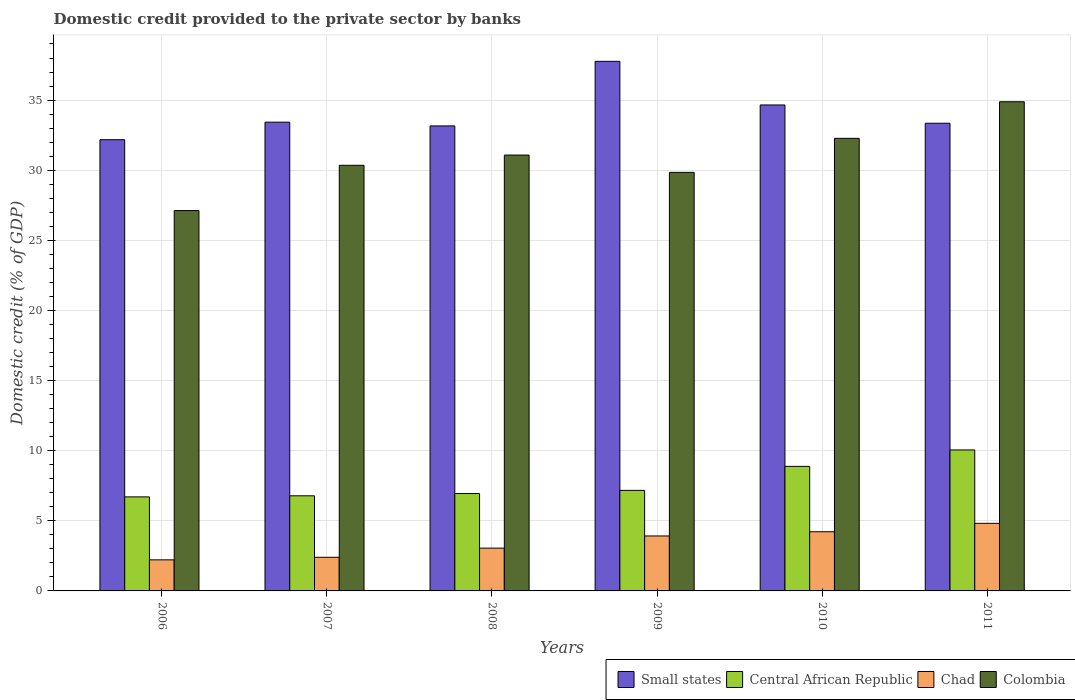How many different coloured bars are there?
Provide a short and direct response. 4. How many groups of bars are there?
Your answer should be very brief. 6. Are the number of bars per tick equal to the number of legend labels?
Make the answer very short. Yes. How many bars are there on the 4th tick from the left?
Your answer should be compact. 4. How many bars are there on the 3rd tick from the right?
Your answer should be very brief. 4. What is the label of the 4th group of bars from the left?
Your answer should be very brief. 2009. What is the domestic credit provided to the private sector by banks in Small states in 2009?
Your answer should be very brief. 37.76. Across all years, what is the maximum domestic credit provided to the private sector by banks in Small states?
Your answer should be compact. 37.76. Across all years, what is the minimum domestic credit provided to the private sector by banks in Central African Republic?
Keep it short and to the point. 6.71. In which year was the domestic credit provided to the private sector by banks in Chad maximum?
Provide a short and direct response. 2011. In which year was the domestic credit provided to the private sector by banks in Central African Republic minimum?
Offer a very short reply. 2006. What is the total domestic credit provided to the private sector by banks in Small states in the graph?
Provide a succinct answer. 204.53. What is the difference between the domestic credit provided to the private sector by banks in Chad in 2006 and that in 2009?
Ensure brevity in your answer.  -1.7. What is the difference between the domestic credit provided to the private sector by banks in Chad in 2010 and the domestic credit provided to the private sector by banks in Small states in 2006?
Your response must be concise. -27.96. What is the average domestic credit provided to the private sector by banks in Chad per year?
Keep it short and to the point. 3.44. In the year 2011, what is the difference between the domestic credit provided to the private sector by banks in Chad and domestic credit provided to the private sector by banks in Colombia?
Provide a succinct answer. -30.06. What is the ratio of the domestic credit provided to the private sector by banks in Central African Republic in 2006 to that in 2007?
Your response must be concise. 0.99. What is the difference between the highest and the second highest domestic credit provided to the private sector by banks in Central African Republic?
Offer a very short reply. 1.17. What is the difference between the highest and the lowest domestic credit provided to the private sector by banks in Small states?
Provide a short and direct response. 5.59. In how many years, is the domestic credit provided to the private sector by banks in Central African Republic greater than the average domestic credit provided to the private sector by banks in Central African Republic taken over all years?
Your response must be concise. 2. Is the sum of the domestic credit provided to the private sector by banks in Chad in 2008 and 2011 greater than the maximum domestic credit provided to the private sector by banks in Colombia across all years?
Offer a terse response. No. What does the 1st bar from the left in 2009 represents?
Keep it short and to the point. Small states. Is it the case that in every year, the sum of the domestic credit provided to the private sector by banks in Colombia and domestic credit provided to the private sector by banks in Chad is greater than the domestic credit provided to the private sector by banks in Central African Republic?
Your response must be concise. Yes. How many bars are there?
Your response must be concise. 24. Are all the bars in the graph horizontal?
Keep it short and to the point. No. What is the difference between two consecutive major ticks on the Y-axis?
Your answer should be compact. 5. Does the graph contain grids?
Offer a terse response. Yes. Where does the legend appear in the graph?
Your answer should be very brief. Bottom right. What is the title of the graph?
Provide a short and direct response. Domestic credit provided to the private sector by banks. Does "Slovak Republic" appear as one of the legend labels in the graph?
Provide a short and direct response. No. What is the label or title of the X-axis?
Make the answer very short. Years. What is the label or title of the Y-axis?
Make the answer very short. Domestic credit (% of GDP). What is the Domestic credit (% of GDP) in Small states in 2006?
Make the answer very short. 32.18. What is the Domestic credit (% of GDP) of Central African Republic in 2006?
Keep it short and to the point. 6.71. What is the Domestic credit (% of GDP) of Chad in 2006?
Offer a terse response. 2.22. What is the Domestic credit (% of GDP) of Colombia in 2006?
Provide a short and direct response. 27.12. What is the Domestic credit (% of GDP) in Small states in 2007?
Offer a very short reply. 33.43. What is the Domestic credit (% of GDP) in Central African Republic in 2007?
Keep it short and to the point. 6.78. What is the Domestic credit (% of GDP) in Chad in 2007?
Give a very brief answer. 2.4. What is the Domestic credit (% of GDP) in Colombia in 2007?
Offer a very short reply. 30.35. What is the Domestic credit (% of GDP) in Small states in 2008?
Make the answer very short. 33.16. What is the Domestic credit (% of GDP) of Central African Republic in 2008?
Make the answer very short. 6.94. What is the Domestic credit (% of GDP) of Chad in 2008?
Your answer should be very brief. 3.05. What is the Domestic credit (% of GDP) in Colombia in 2008?
Your response must be concise. 31.08. What is the Domestic credit (% of GDP) in Small states in 2009?
Provide a short and direct response. 37.76. What is the Domestic credit (% of GDP) in Central African Republic in 2009?
Provide a short and direct response. 7.17. What is the Domestic credit (% of GDP) of Chad in 2009?
Provide a succinct answer. 3.92. What is the Domestic credit (% of GDP) of Colombia in 2009?
Offer a terse response. 29.85. What is the Domestic credit (% of GDP) of Small states in 2010?
Ensure brevity in your answer.  34.65. What is the Domestic credit (% of GDP) in Central African Republic in 2010?
Provide a succinct answer. 8.88. What is the Domestic credit (% of GDP) in Chad in 2010?
Your answer should be very brief. 4.22. What is the Domestic credit (% of GDP) in Colombia in 2010?
Provide a succinct answer. 32.27. What is the Domestic credit (% of GDP) of Small states in 2011?
Your answer should be very brief. 33.35. What is the Domestic credit (% of GDP) of Central African Republic in 2011?
Ensure brevity in your answer.  10.05. What is the Domestic credit (% of GDP) of Chad in 2011?
Make the answer very short. 4.82. What is the Domestic credit (% of GDP) in Colombia in 2011?
Your answer should be compact. 34.88. Across all years, what is the maximum Domestic credit (% of GDP) of Small states?
Keep it short and to the point. 37.76. Across all years, what is the maximum Domestic credit (% of GDP) in Central African Republic?
Provide a short and direct response. 10.05. Across all years, what is the maximum Domestic credit (% of GDP) in Chad?
Offer a terse response. 4.82. Across all years, what is the maximum Domestic credit (% of GDP) of Colombia?
Your answer should be very brief. 34.88. Across all years, what is the minimum Domestic credit (% of GDP) in Small states?
Your response must be concise. 32.18. Across all years, what is the minimum Domestic credit (% of GDP) in Central African Republic?
Your answer should be very brief. 6.71. Across all years, what is the minimum Domestic credit (% of GDP) in Chad?
Your answer should be very brief. 2.22. Across all years, what is the minimum Domestic credit (% of GDP) in Colombia?
Provide a short and direct response. 27.12. What is the total Domestic credit (% of GDP) of Small states in the graph?
Give a very brief answer. 204.53. What is the total Domestic credit (% of GDP) in Central African Republic in the graph?
Offer a terse response. 46.54. What is the total Domestic credit (% of GDP) of Chad in the graph?
Your answer should be very brief. 20.62. What is the total Domestic credit (% of GDP) in Colombia in the graph?
Your answer should be very brief. 185.56. What is the difference between the Domestic credit (% of GDP) in Small states in 2006 and that in 2007?
Make the answer very short. -1.25. What is the difference between the Domestic credit (% of GDP) of Central African Republic in 2006 and that in 2007?
Give a very brief answer. -0.08. What is the difference between the Domestic credit (% of GDP) in Chad in 2006 and that in 2007?
Keep it short and to the point. -0.18. What is the difference between the Domestic credit (% of GDP) in Colombia in 2006 and that in 2007?
Your answer should be very brief. -3.23. What is the difference between the Domestic credit (% of GDP) in Small states in 2006 and that in 2008?
Offer a terse response. -0.98. What is the difference between the Domestic credit (% of GDP) of Central African Republic in 2006 and that in 2008?
Offer a very short reply. -0.24. What is the difference between the Domestic credit (% of GDP) of Chad in 2006 and that in 2008?
Give a very brief answer. -0.84. What is the difference between the Domestic credit (% of GDP) in Colombia in 2006 and that in 2008?
Give a very brief answer. -3.96. What is the difference between the Domestic credit (% of GDP) of Small states in 2006 and that in 2009?
Make the answer very short. -5.59. What is the difference between the Domestic credit (% of GDP) of Central African Republic in 2006 and that in 2009?
Provide a succinct answer. -0.46. What is the difference between the Domestic credit (% of GDP) in Chad in 2006 and that in 2009?
Offer a very short reply. -1.7. What is the difference between the Domestic credit (% of GDP) in Colombia in 2006 and that in 2009?
Offer a terse response. -2.72. What is the difference between the Domestic credit (% of GDP) of Small states in 2006 and that in 2010?
Offer a terse response. -2.48. What is the difference between the Domestic credit (% of GDP) in Central African Republic in 2006 and that in 2010?
Give a very brief answer. -2.18. What is the difference between the Domestic credit (% of GDP) of Chad in 2006 and that in 2010?
Keep it short and to the point. -2.01. What is the difference between the Domestic credit (% of GDP) of Colombia in 2006 and that in 2010?
Provide a succinct answer. -5.15. What is the difference between the Domestic credit (% of GDP) of Small states in 2006 and that in 2011?
Make the answer very short. -1.17. What is the difference between the Domestic credit (% of GDP) in Central African Republic in 2006 and that in 2011?
Ensure brevity in your answer.  -3.35. What is the difference between the Domestic credit (% of GDP) in Chad in 2006 and that in 2011?
Give a very brief answer. -2.6. What is the difference between the Domestic credit (% of GDP) of Colombia in 2006 and that in 2011?
Provide a succinct answer. -7.76. What is the difference between the Domestic credit (% of GDP) in Small states in 2007 and that in 2008?
Provide a succinct answer. 0.27. What is the difference between the Domestic credit (% of GDP) of Central African Republic in 2007 and that in 2008?
Offer a terse response. -0.16. What is the difference between the Domestic credit (% of GDP) in Chad in 2007 and that in 2008?
Give a very brief answer. -0.65. What is the difference between the Domestic credit (% of GDP) in Colombia in 2007 and that in 2008?
Make the answer very short. -0.73. What is the difference between the Domestic credit (% of GDP) in Small states in 2007 and that in 2009?
Ensure brevity in your answer.  -4.34. What is the difference between the Domestic credit (% of GDP) of Central African Republic in 2007 and that in 2009?
Provide a short and direct response. -0.39. What is the difference between the Domestic credit (% of GDP) of Chad in 2007 and that in 2009?
Your answer should be very brief. -1.52. What is the difference between the Domestic credit (% of GDP) in Colombia in 2007 and that in 2009?
Keep it short and to the point. 0.51. What is the difference between the Domestic credit (% of GDP) of Small states in 2007 and that in 2010?
Your answer should be very brief. -1.23. What is the difference between the Domestic credit (% of GDP) in Central African Republic in 2007 and that in 2010?
Your response must be concise. -2.1. What is the difference between the Domestic credit (% of GDP) of Chad in 2007 and that in 2010?
Your answer should be very brief. -1.82. What is the difference between the Domestic credit (% of GDP) of Colombia in 2007 and that in 2010?
Provide a succinct answer. -1.92. What is the difference between the Domestic credit (% of GDP) in Small states in 2007 and that in 2011?
Make the answer very short. 0.08. What is the difference between the Domestic credit (% of GDP) in Central African Republic in 2007 and that in 2011?
Make the answer very short. -3.27. What is the difference between the Domestic credit (% of GDP) of Chad in 2007 and that in 2011?
Provide a succinct answer. -2.42. What is the difference between the Domestic credit (% of GDP) in Colombia in 2007 and that in 2011?
Make the answer very short. -4.53. What is the difference between the Domestic credit (% of GDP) in Small states in 2008 and that in 2009?
Your answer should be very brief. -4.6. What is the difference between the Domestic credit (% of GDP) of Central African Republic in 2008 and that in 2009?
Provide a succinct answer. -0.23. What is the difference between the Domestic credit (% of GDP) in Chad in 2008 and that in 2009?
Provide a short and direct response. -0.87. What is the difference between the Domestic credit (% of GDP) in Colombia in 2008 and that in 2009?
Offer a terse response. 1.24. What is the difference between the Domestic credit (% of GDP) in Small states in 2008 and that in 2010?
Provide a short and direct response. -1.49. What is the difference between the Domestic credit (% of GDP) in Central African Republic in 2008 and that in 2010?
Provide a succinct answer. -1.94. What is the difference between the Domestic credit (% of GDP) in Chad in 2008 and that in 2010?
Your response must be concise. -1.17. What is the difference between the Domestic credit (% of GDP) in Colombia in 2008 and that in 2010?
Your response must be concise. -1.19. What is the difference between the Domestic credit (% of GDP) of Small states in 2008 and that in 2011?
Provide a short and direct response. -0.19. What is the difference between the Domestic credit (% of GDP) of Central African Republic in 2008 and that in 2011?
Make the answer very short. -3.11. What is the difference between the Domestic credit (% of GDP) of Chad in 2008 and that in 2011?
Offer a terse response. -1.77. What is the difference between the Domestic credit (% of GDP) of Colombia in 2008 and that in 2011?
Offer a very short reply. -3.8. What is the difference between the Domestic credit (% of GDP) of Small states in 2009 and that in 2010?
Give a very brief answer. 3.11. What is the difference between the Domestic credit (% of GDP) of Central African Republic in 2009 and that in 2010?
Your answer should be very brief. -1.71. What is the difference between the Domestic credit (% of GDP) in Chad in 2009 and that in 2010?
Provide a short and direct response. -0.3. What is the difference between the Domestic credit (% of GDP) of Colombia in 2009 and that in 2010?
Ensure brevity in your answer.  -2.43. What is the difference between the Domestic credit (% of GDP) in Small states in 2009 and that in 2011?
Your answer should be compact. 4.41. What is the difference between the Domestic credit (% of GDP) in Central African Republic in 2009 and that in 2011?
Offer a terse response. -2.88. What is the difference between the Domestic credit (% of GDP) of Chad in 2009 and that in 2011?
Make the answer very short. -0.9. What is the difference between the Domestic credit (% of GDP) of Colombia in 2009 and that in 2011?
Provide a short and direct response. -5.04. What is the difference between the Domestic credit (% of GDP) of Small states in 2010 and that in 2011?
Provide a short and direct response. 1.3. What is the difference between the Domestic credit (% of GDP) of Central African Republic in 2010 and that in 2011?
Your answer should be compact. -1.17. What is the difference between the Domestic credit (% of GDP) in Chad in 2010 and that in 2011?
Offer a very short reply. -0.6. What is the difference between the Domestic credit (% of GDP) in Colombia in 2010 and that in 2011?
Provide a short and direct response. -2.61. What is the difference between the Domestic credit (% of GDP) of Small states in 2006 and the Domestic credit (% of GDP) of Central African Republic in 2007?
Offer a terse response. 25.39. What is the difference between the Domestic credit (% of GDP) of Small states in 2006 and the Domestic credit (% of GDP) of Chad in 2007?
Keep it short and to the point. 29.78. What is the difference between the Domestic credit (% of GDP) in Small states in 2006 and the Domestic credit (% of GDP) in Colombia in 2007?
Provide a succinct answer. 1.83. What is the difference between the Domestic credit (% of GDP) of Central African Republic in 2006 and the Domestic credit (% of GDP) of Chad in 2007?
Your answer should be compact. 4.31. What is the difference between the Domestic credit (% of GDP) of Central African Republic in 2006 and the Domestic credit (% of GDP) of Colombia in 2007?
Your answer should be very brief. -23.64. What is the difference between the Domestic credit (% of GDP) of Chad in 2006 and the Domestic credit (% of GDP) of Colombia in 2007?
Ensure brevity in your answer.  -28.14. What is the difference between the Domestic credit (% of GDP) of Small states in 2006 and the Domestic credit (% of GDP) of Central African Republic in 2008?
Provide a succinct answer. 25.23. What is the difference between the Domestic credit (% of GDP) in Small states in 2006 and the Domestic credit (% of GDP) in Chad in 2008?
Ensure brevity in your answer.  29.12. What is the difference between the Domestic credit (% of GDP) of Small states in 2006 and the Domestic credit (% of GDP) of Colombia in 2008?
Your answer should be compact. 1.09. What is the difference between the Domestic credit (% of GDP) in Central African Republic in 2006 and the Domestic credit (% of GDP) in Chad in 2008?
Offer a very short reply. 3.65. What is the difference between the Domestic credit (% of GDP) of Central African Republic in 2006 and the Domestic credit (% of GDP) of Colombia in 2008?
Make the answer very short. -24.38. What is the difference between the Domestic credit (% of GDP) of Chad in 2006 and the Domestic credit (% of GDP) of Colombia in 2008?
Provide a short and direct response. -28.87. What is the difference between the Domestic credit (% of GDP) of Small states in 2006 and the Domestic credit (% of GDP) of Central African Republic in 2009?
Offer a terse response. 25.01. What is the difference between the Domestic credit (% of GDP) of Small states in 2006 and the Domestic credit (% of GDP) of Chad in 2009?
Provide a succinct answer. 28.26. What is the difference between the Domestic credit (% of GDP) of Small states in 2006 and the Domestic credit (% of GDP) of Colombia in 2009?
Give a very brief answer. 2.33. What is the difference between the Domestic credit (% of GDP) in Central African Republic in 2006 and the Domestic credit (% of GDP) in Chad in 2009?
Provide a short and direct response. 2.79. What is the difference between the Domestic credit (% of GDP) in Central African Republic in 2006 and the Domestic credit (% of GDP) in Colombia in 2009?
Provide a short and direct response. -23.14. What is the difference between the Domestic credit (% of GDP) in Chad in 2006 and the Domestic credit (% of GDP) in Colombia in 2009?
Provide a short and direct response. -27.63. What is the difference between the Domestic credit (% of GDP) of Small states in 2006 and the Domestic credit (% of GDP) of Central African Republic in 2010?
Ensure brevity in your answer.  23.29. What is the difference between the Domestic credit (% of GDP) in Small states in 2006 and the Domestic credit (% of GDP) in Chad in 2010?
Make the answer very short. 27.96. What is the difference between the Domestic credit (% of GDP) in Small states in 2006 and the Domestic credit (% of GDP) in Colombia in 2010?
Offer a very short reply. -0.1. What is the difference between the Domestic credit (% of GDP) of Central African Republic in 2006 and the Domestic credit (% of GDP) of Chad in 2010?
Your response must be concise. 2.49. What is the difference between the Domestic credit (% of GDP) of Central African Republic in 2006 and the Domestic credit (% of GDP) of Colombia in 2010?
Provide a short and direct response. -25.57. What is the difference between the Domestic credit (% of GDP) in Chad in 2006 and the Domestic credit (% of GDP) in Colombia in 2010?
Make the answer very short. -30.06. What is the difference between the Domestic credit (% of GDP) in Small states in 2006 and the Domestic credit (% of GDP) in Central African Republic in 2011?
Provide a short and direct response. 22.12. What is the difference between the Domestic credit (% of GDP) of Small states in 2006 and the Domestic credit (% of GDP) of Chad in 2011?
Your answer should be compact. 27.36. What is the difference between the Domestic credit (% of GDP) in Small states in 2006 and the Domestic credit (% of GDP) in Colombia in 2011?
Provide a short and direct response. -2.71. What is the difference between the Domestic credit (% of GDP) of Central African Republic in 2006 and the Domestic credit (% of GDP) of Chad in 2011?
Offer a very short reply. 1.89. What is the difference between the Domestic credit (% of GDP) in Central African Republic in 2006 and the Domestic credit (% of GDP) in Colombia in 2011?
Make the answer very short. -28.18. What is the difference between the Domestic credit (% of GDP) in Chad in 2006 and the Domestic credit (% of GDP) in Colombia in 2011?
Make the answer very short. -32.67. What is the difference between the Domestic credit (% of GDP) in Small states in 2007 and the Domestic credit (% of GDP) in Central African Republic in 2008?
Offer a terse response. 26.48. What is the difference between the Domestic credit (% of GDP) in Small states in 2007 and the Domestic credit (% of GDP) in Chad in 2008?
Provide a short and direct response. 30.37. What is the difference between the Domestic credit (% of GDP) in Small states in 2007 and the Domestic credit (% of GDP) in Colombia in 2008?
Your answer should be very brief. 2.34. What is the difference between the Domestic credit (% of GDP) of Central African Republic in 2007 and the Domestic credit (% of GDP) of Chad in 2008?
Provide a short and direct response. 3.73. What is the difference between the Domestic credit (% of GDP) in Central African Republic in 2007 and the Domestic credit (% of GDP) in Colombia in 2008?
Keep it short and to the point. -24.3. What is the difference between the Domestic credit (% of GDP) in Chad in 2007 and the Domestic credit (% of GDP) in Colombia in 2008?
Provide a short and direct response. -28.68. What is the difference between the Domestic credit (% of GDP) of Small states in 2007 and the Domestic credit (% of GDP) of Central African Republic in 2009?
Your response must be concise. 26.26. What is the difference between the Domestic credit (% of GDP) in Small states in 2007 and the Domestic credit (% of GDP) in Chad in 2009?
Your answer should be very brief. 29.51. What is the difference between the Domestic credit (% of GDP) in Small states in 2007 and the Domestic credit (% of GDP) in Colombia in 2009?
Make the answer very short. 3.58. What is the difference between the Domestic credit (% of GDP) of Central African Republic in 2007 and the Domestic credit (% of GDP) of Chad in 2009?
Provide a short and direct response. 2.86. What is the difference between the Domestic credit (% of GDP) of Central African Republic in 2007 and the Domestic credit (% of GDP) of Colombia in 2009?
Offer a terse response. -23.06. What is the difference between the Domestic credit (% of GDP) in Chad in 2007 and the Domestic credit (% of GDP) in Colombia in 2009?
Your answer should be very brief. -27.45. What is the difference between the Domestic credit (% of GDP) in Small states in 2007 and the Domestic credit (% of GDP) in Central African Republic in 2010?
Your answer should be compact. 24.54. What is the difference between the Domestic credit (% of GDP) of Small states in 2007 and the Domestic credit (% of GDP) of Chad in 2010?
Your response must be concise. 29.21. What is the difference between the Domestic credit (% of GDP) of Small states in 2007 and the Domestic credit (% of GDP) of Colombia in 2010?
Offer a very short reply. 1.15. What is the difference between the Domestic credit (% of GDP) in Central African Republic in 2007 and the Domestic credit (% of GDP) in Chad in 2010?
Provide a succinct answer. 2.56. What is the difference between the Domestic credit (% of GDP) of Central African Republic in 2007 and the Domestic credit (% of GDP) of Colombia in 2010?
Your response must be concise. -25.49. What is the difference between the Domestic credit (% of GDP) of Chad in 2007 and the Domestic credit (% of GDP) of Colombia in 2010?
Your answer should be compact. -29.88. What is the difference between the Domestic credit (% of GDP) in Small states in 2007 and the Domestic credit (% of GDP) in Central African Republic in 2011?
Keep it short and to the point. 23.37. What is the difference between the Domestic credit (% of GDP) in Small states in 2007 and the Domestic credit (% of GDP) in Chad in 2011?
Offer a terse response. 28.61. What is the difference between the Domestic credit (% of GDP) in Small states in 2007 and the Domestic credit (% of GDP) in Colombia in 2011?
Provide a succinct answer. -1.46. What is the difference between the Domestic credit (% of GDP) of Central African Republic in 2007 and the Domestic credit (% of GDP) of Chad in 2011?
Offer a terse response. 1.96. What is the difference between the Domestic credit (% of GDP) of Central African Republic in 2007 and the Domestic credit (% of GDP) of Colombia in 2011?
Your response must be concise. -28.1. What is the difference between the Domestic credit (% of GDP) of Chad in 2007 and the Domestic credit (% of GDP) of Colombia in 2011?
Provide a short and direct response. -32.48. What is the difference between the Domestic credit (% of GDP) of Small states in 2008 and the Domestic credit (% of GDP) of Central African Republic in 2009?
Make the answer very short. 25.99. What is the difference between the Domestic credit (% of GDP) of Small states in 2008 and the Domestic credit (% of GDP) of Chad in 2009?
Offer a very short reply. 29.24. What is the difference between the Domestic credit (% of GDP) of Small states in 2008 and the Domestic credit (% of GDP) of Colombia in 2009?
Offer a very short reply. 3.31. What is the difference between the Domestic credit (% of GDP) in Central African Republic in 2008 and the Domestic credit (% of GDP) in Chad in 2009?
Provide a short and direct response. 3.03. What is the difference between the Domestic credit (% of GDP) in Central African Republic in 2008 and the Domestic credit (% of GDP) in Colombia in 2009?
Provide a succinct answer. -22.9. What is the difference between the Domestic credit (% of GDP) of Chad in 2008 and the Domestic credit (% of GDP) of Colombia in 2009?
Ensure brevity in your answer.  -26.79. What is the difference between the Domestic credit (% of GDP) of Small states in 2008 and the Domestic credit (% of GDP) of Central African Republic in 2010?
Your answer should be compact. 24.28. What is the difference between the Domestic credit (% of GDP) in Small states in 2008 and the Domestic credit (% of GDP) in Chad in 2010?
Your answer should be very brief. 28.94. What is the difference between the Domestic credit (% of GDP) of Small states in 2008 and the Domestic credit (% of GDP) of Colombia in 2010?
Offer a terse response. 0.89. What is the difference between the Domestic credit (% of GDP) of Central African Republic in 2008 and the Domestic credit (% of GDP) of Chad in 2010?
Offer a terse response. 2.72. What is the difference between the Domestic credit (% of GDP) in Central African Republic in 2008 and the Domestic credit (% of GDP) in Colombia in 2010?
Your response must be concise. -25.33. What is the difference between the Domestic credit (% of GDP) of Chad in 2008 and the Domestic credit (% of GDP) of Colombia in 2010?
Offer a very short reply. -29.22. What is the difference between the Domestic credit (% of GDP) of Small states in 2008 and the Domestic credit (% of GDP) of Central African Republic in 2011?
Your answer should be compact. 23.11. What is the difference between the Domestic credit (% of GDP) in Small states in 2008 and the Domestic credit (% of GDP) in Chad in 2011?
Your answer should be compact. 28.34. What is the difference between the Domestic credit (% of GDP) in Small states in 2008 and the Domestic credit (% of GDP) in Colombia in 2011?
Your answer should be compact. -1.72. What is the difference between the Domestic credit (% of GDP) in Central African Republic in 2008 and the Domestic credit (% of GDP) in Chad in 2011?
Provide a short and direct response. 2.12. What is the difference between the Domestic credit (% of GDP) in Central African Republic in 2008 and the Domestic credit (% of GDP) in Colombia in 2011?
Offer a terse response. -27.94. What is the difference between the Domestic credit (% of GDP) of Chad in 2008 and the Domestic credit (% of GDP) of Colombia in 2011?
Provide a succinct answer. -31.83. What is the difference between the Domestic credit (% of GDP) in Small states in 2009 and the Domestic credit (% of GDP) in Central African Republic in 2010?
Your answer should be compact. 28.88. What is the difference between the Domestic credit (% of GDP) of Small states in 2009 and the Domestic credit (% of GDP) of Chad in 2010?
Your answer should be very brief. 33.54. What is the difference between the Domestic credit (% of GDP) in Small states in 2009 and the Domestic credit (% of GDP) in Colombia in 2010?
Offer a very short reply. 5.49. What is the difference between the Domestic credit (% of GDP) of Central African Republic in 2009 and the Domestic credit (% of GDP) of Chad in 2010?
Offer a terse response. 2.95. What is the difference between the Domestic credit (% of GDP) in Central African Republic in 2009 and the Domestic credit (% of GDP) in Colombia in 2010?
Offer a terse response. -25.1. What is the difference between the Domestic credit (% of GDP) of Chad in 2009 and the Domestic credit (% of GDP) of Colombia in 2010?
Make the answer very short. -28.35. What is the difference between the Domestic credit (% of GDP) in Small states in 2009 and the Domestic credit (% of GDP) in Central African Republic in 2011?
Your response must be concise. 27.71. What is the difference between the Domestic credit (% of GDP) of Small states in 2009 and the Domestic credit (% of GDP) of Chad in 2011?
Offer a terse response. 32.94. What is the difference between the Domestic credit (% of GDP) of Small states in 2009 and the Domestic credit (% of GDP) of Colombia in 2011?
Give a very brief answer. 2.88. What is the difference between the Domestic credit (% of GDP) in Central African Republic in 2009 and the Domestic credit (% of GDP) in Chad in 2011?
Make the answer very short. 2.35. What is the difference between the Domestic credit (% of GDP) of Central African Republic in 2009 and the Domestic credit (% of GDP) of Colombia in 2011?
Provide a succinct answer. -27.71. What is the difference between the Domestic credit (% of GDP) in Chad in 2009 and the Domestic credit (% of GDP) in Colombia in 2011?
Your answer should be very brief. -30.96. What is the difference between the Domestic credit (% of GDP) of Small states in 2010 and the Domestic credit (% of GDP) of Central African Republic in 2011?
Your answer should be very brief. 24.6. What is the difference between the Domestic credit (% of GDP) in Small states in 2010 and the Domestic credit (% of GDP) in Chad in 2011?
Offer a very short reply. 29.83. What is the difference between the Domestic credit (% of GDP) of Small states in 2010 and the Domestic credit (% of GDP) of Colombia in 2011?
Make the answer very short. -0.23. What is the difference between the Domestic credit (% of GDP) of Central African Republic in 2010 and the Domestic credit (% of GDP) of Chad in 2011?
Give a very brief answer. 4.06. What is the difference between the Domestic credit (% of GDP) of Central African Republic in 2010 and the Domestic credit (% of GDP) of Colombia in 2011?
Keep it short and to the point. -26. What is the difference between the Domestic credit (% of GDP) in Chad in 2010 and the Domestic credit (% of GDP) in Colombia in 2011?
Give a very brief answer. -30.66. What is the average Domestic credit (% of GDP) in Small states per year?
Ensure brevity in your answer.  34.09. What is the average Domestic credit (% of GDP) in Central African Republic per year?
Provide a short and direct response. 7.76. What is the average Domestic credit (% of GDP) in Chad per year?
Provide a short and direct response. 3.44. What is the average Domestic credit (% of GDP) in Colombia per year?
Offer a terse response. 30.93. In the year 2006, what is the difference between the Domestic credit (% of GDP) in Small states and Domestic credit (% of GDP) in Central African Republic?
Make the answer very short. 25.47. In the year 2006, what is the difference between the Domestic credit (% of GDP) in Small states and Domestic credit (% of GDP) in Chad?
Offer a very short reply. 29.96. In the year 2006, what is the difference between the Domestic credit (% of GDP) in Small states and Domestic credit (% of GDP) in Colombia?
Provide a succinct answer. 5.05. In the year 2006, what is the difference between the Domestic credit (% of GDP) of Central African Republic and Domestic credit (% of GDP) of Chad?
Offer a very short reply. 4.49. In the year 2006, what is the difference between the Domestic credit (% of GDP) in Central African Republic and Domestic credit (% of GDP) in Colombia?
Your answer should be compact. -20.42. In the year 2006, what is the difference between the Domestic credit (% of GDP) of Chad and Domestic credit (% of GDP) of Colombia?
Provide a succinct answer. -24.91. In the year 2007, what is the difference between the Domestic credit (% of GDP) of Small states and Domestic credit (% of GDP) of Central African Republic?
Make the answer very short. 26.64. In the year 2007, what is the difference between the Domestic credit (% of GDP) of Small states and Domestic credit (% of GDP) of Chad?
Your answer should be compact. 31.03. In the year 2007, what is the difference between the Domestic credit (% of GDP) in Small states and Domestic credit (% of GDP) in Colombia?
Make the answer very short. 3.08. In the year 2007, what is the difference between the Domestic credit (% of GDP) in Central African Republic and Domestic credit (% of GDP) in Chad?
Your answer should be compact. 4.39. In the year 2007, what is the difference between the Domestic credit (% of GDP) of Central African Republic and Domestic credit (% of GDP) of Colombia?
Provide a short and direct response. -23.57. In the year 2007, what is the difference between the Domestic credit (% of GDP) of Chad and Domestic credit (% of GDP) of Colombia?
Provide a short and direct response. -27.95. In the year 2008, what is the difference between the Domestic credit (% of GDP) in Small states and Domestic credit (% of GDP) in Central African Republic?
Ensure brevity in your answer.  26.22. In the year 2008, what is the difference between the Domestic credit (% of GDP) in Small states and Domestic credit (% of GDP) in Chad?
Your answer should be very brief. 30.11. In the year 2008, what is the difference between the Domestic credit (% of GDP) of Small states and Domestic credit (% of GDP) of Colombia?
Your response must be concise. 2.08. In the year 2008, what is the difference between the Domestic credit (% of GDP) in Central African Republic and Domestic credit (% of GDP) in Chad?
Provide a short and direct response. 3.89. In the year 2008, what is the difference between the Domestic credit (% of GDP) in Central African Republic and Domestic credit (% of GDP) in Colombia?
Give a very brief answer. -24.14. In the year 2008, what is the difference between the Domestic credit (% of GDP) in Chad and Domestic credit (% of GDP) in Colombia?
Your answer should be very brief. -28.03. In the year 2009, what is the difference between the Domestic credit (% of GDP) of Small states and Domestic credit (% of GDP) of Central African Republic?
Provide a short and direct response. 30.59. In the year 2009, what is the difference between the Domestic credit (% of GDP) of Small states and Domestic credit (% of GDP) of Chad?
Your answer should be compact. 33.84. In the year 2009, what is the difference between the Domestic credit (% of GDP) in Small states and Domestic credit (% of GDP) in Colombia?
Your answer should be compact. 7.92. In the year 2009, what is the difference between the Domestic credit (% of GDP) in Central African Republic and Domestic credit (% of GDP) in Chad?
Your answer should be very brief. 3.25. In the year 2009, what is the difference between the Domestic credit (% of GDP) of Central African Republic and Domestic credit (% of GDP) of Colombia?
Give a very brief answer. -22.68. In the year 2009, what is the difference between the Domestic credit (% of GDP) of Chad and Domestic credit (% of GDP) of Colombia?
Your answer should be compact. -25.93. In the year 2010, what is the difference between the Domestic credit (% of GDP) in Small states and Domestic credit (% of GDP) in Central African Republic?
Ensure brevity in your answer.  25.77. In the year 2010, what is the difference between the Domestic credit (% of GDP) in Small states and Domestic credit (% of GDP) in Chad?
Your response must be concise. 30.43. In the year 2010, what is the difference between the Domestic credit (% of GDP) of Small states and Domestic credit (% of GDP) of Colombia?
Your answer should be compact. 2.38. In the year 2010, what is the difference between the Domestic credit (% of GDP) of Central African Republic and Domestic credit (% of GDP) of Chad?
Give a very brief answer. 4.66. In the year 2010, what is the difference between the Domestic credit (% of GDP) in Central African Republic and Domestic credit (% of GDP) in Colombia?
Your answer should be very brief. -23.39. In the year 2010, what is the difference between the Domestic credit (% of GDP) of Chad and Domestic credit (% of GDP) of Colombia?
Your answer should be compact. -28.05. In the year 2011, what is the difference between the Domestic credit (% of GDP) of Small states and Domestic credit (% of GDP) of Central African Republic?
Provide a short and direct response. 23.3. In the year 2011, what is the difference between the Domestic credit (% of GDP) in Small states and Domestic credit (% of GDP) in Chad?
Ensure brevity in your answer.  28.53. In the year 2011, what is the difference between the Domestic credit (% of GDP) of Small states and Domestic credit (% of GDP) of Colombia?
Your response must be concise. -1.53. In the year 2011, what is the difference between the Domestic credit (% of GDP) in Central African Republic and Domestic credit (% of GDP) in Chad?
Your response must be concise. 5.23. In the year 2011, what is the difference between the Domestic credit (% of GDP) of Central African Republic and Domestic credit (% of GDP) of Colombia?
Offer a terse response. -24.83. In the year 2011, what is the difference between the Domestic credit (% of GDP) in Chad and Domestic credit (% of GDP) in Colombia?
Make the answer very short. -30.06. What is the ratio of the Domestic credit (% of GDP) of Small states in 2006 to that in 2007?
Give a very brief answer. 0.96. What is the ratio of the Domestic credit (% of GDP) of Central African Republic in 2006 to that in 2007?
Your answer should be very brief. 0.99. What is the ratio of the Domestic credit (% of GDP) of Chad in 2006 to that in 2007?
Your answer should be compact. 0.92. What is the ratio of the Domestic credit (% of GDP) of Colombia in 2006 to that in 2007?
Offer a terse response. 0.89. What is the ratio of the Domestic credit (% of GDP) in Small states in 2006 to that in 2008?
Give a very brief answer. 0.97. What is the ratio of the Domestic credit (% of GDP) in Central African Republic in 2006 to that in 2008?
Offer a terse response. 0.97. What is the ratio of the Domestic credit (% of GDP) of Chad in 2006 to that in 2008?
Your answer should be very brief. 0.73. What is the ratio of the Domestic credit (% of GDP) of Colombia in 2006 to that in 2008?
Offer a very short reply. 0.87. What is the ratio of the Domestic credit (% of GDP) of Small states in 2006 to that in 2009?
Keep it short and to the point. 0.85. What is the ratio of the Domestic credit (% of GDP) in Central African Republic in 2006 to that in 2009?
Make the answer very short. 0.94. What is the ratio of the Domestic credit (% of GDP) in Chad in 2006 to that in 2009?
Your answer should be very brief. 0.57. What is the ratio of the Domestic credit (% of GDP) of Colombia in 2006 to that in 2009?
Offer a very short reply. 0.91. What is the ratio of the Domestic credit (% of GDP) of Small states in 2006 to that in 2010?
Make the answer very short. 0.93. What is the ratio of the Domestic credit (% of GDP) of Central African Republic in 2006 to that in 2010?
Offer a very short reply. 0.76. What is the ratio of the Domestic credit (% of GDP) in Chad in 2006 to that in 2010?
Offer a very short reply. 0.52. What is the ratio of the Domestic credit (% of GDP) of Colombia in 2006 to that in 2010?
Provide a succinct answer. 0.84. What is the ratio of the Domestic credit (% of GDP) of Small states in 2006 to that in 2011?
Make the answer very short. 0.96. What is the ratio of the Domestic credit (% of GDP) of Central African Republic in 2006 to that in 2011?
Your response must be concise. 0.67. What is the ratio of the Domestic credit (% of GDP) in Chad in 2006 to that in 2011?
Provide a short and direct response. 0.46. What is the ratio of the Domestic credit (% of GDP) of Colombia in 2006 to that in 2011?
Your answer should be compact. 0.78. What is the ratio of the Domestic credit (% of GDP) in Small states in 2007 to that in 2008?
Your answer should be very brief. 1.01. What is the ratio of the Domestic credit (% of GDP) in Central African Republic in 2007 to that in 2008?
Provide a short and direct response. 0.98. What is the ratio of the Domestic credit (% of GDP) in Chad in 2007 to that in 2008?
Offer a very short reply. 0.79. What is the ratio of the Domestic credit (% of GDP) of Colombia in 2007 to that in 2008?
Ensure brevity in your answer.  0.98. What is the ratio of the Domestic credit (% of GDP) of Small states in 2007 to that in 2009?
Your answer should be very brief. 0.89. What is the ratio of the Domestic credit (% of GDP) of Central African Republic in 2007 to that in 2009?
Offer a very short reply. 0.95. What is the ratio of the Domestic credit (% of GDP) in Chad in 2007 to that in 2009?
Make the answer very short. 0.61. What is the ratio of the Domestic credit (% of GDP) in Colombia in 2007 to that in 2009?
Your response must be concise. 1.02. What is the ratio of the Domestic credit (% of GDP) in Small states in 2007 to that in 2010?
Give a very brief answer. 0.96. What is the ratio of the Domestic credit (% of GDP) of Central African Republic in 2007 to that in 2010?
Ensure brevity in your answer.  0.76. What is the ratio of the Domestic credit (% of GDP) of Chad in 2007 to that in 2010?
Offer a very short reply. 0.57. What is the ratio of the Domestic credit (% of GDP) of Colombia in 2007 to that in 2010?
Ensure brevity in your answer.  0.94. What is the ratio of the Domestic credit (% of GDP) of Central African Republic in 2007 to that in 2011?
Make the answer very short. 0.67. What is the ratio of the Domestic credit (% of GDP) of Chad in 2007 to that in 2011?
Your response must be concise. 0.5. What is the ratio of the Domestic credit (% of GDP) of Colombia in 2007 to that in 2011?
Give a very brief answer. 0.87. What is the ratio of the Domestic credit (% of GDP) in Small states in 2008 to that in 2009?
Offer a terse response. 0.88. What is the ratio of the Domestic credit (% of GDP) in Central African Republic in 2008 to that in 2009?
Make the answer very short. 0.97. What is the ratio of the Domestic credit (% of GDP) of Chad in 2008 to that in 2009?
Offer a terse response. 0.78. What is the ratio of the Domestic credit (% of GDP) in Colombia in 2008 to that in 2009?
Provide a succinct answer. 1.04. What is the ratio of the Domestic credit (% of GDP) in Small states in 2008 to that in 2010?
Your answer should be compact. 0.96. What is the ratio of the Domestic credit (% of GDP) in Central African Republic in 2008 to that in 2010?
Your response must be concise. 0.78. What is the ratio of the Domestic credit (% of GDP) in Chad in 2008 to that in 2010?
Give a very brief answer. 0.72. What is the ratio of the Domestic credit (% of GDP) in Colombia in 2008 to that in 2010?
Provide a succinct answer. 0.96. What is the ratio of the Domestic credit (% of GDP) of Small states in 2008 to that in 2011?
Provide a succinct answer. 0.99. What is the ratio of the Domestic credit (% of GDP) in Central African Republic in 2008 to that in 2011?
Offer a very short reply. 0.69. What is the ratio of the Domestic credit (% of GDP) in Chad in 2008 to that in 2011?
Give a very brief answer. 0.63. What is the ratio of the Domestic credit (% of GDP) in Colombia in 2008 to that in 2011?
Give a very brief answer. 0.89. What is the ratio of the Domestic credit (% of GDP) of Small states in 2009 to that in 2010?
Your answer should be compact. 1.09. What is the ratio of the Domestic credit (% of GDP) of Central African Republic in 2009 to that in 2010?
Offer a very short reply. 0.81. What is the ratio of the Domestic credit (% of GDP) in Chad in 2009 to that in 2010?
Ensure brevity in your answer.  0.93. What is the ratio of the Domestic credit (% of GDP) in Colombia in 2009 to that in 2010?
Keep it short and to the point. 0.92. What is the ratio of the Domestic credit (% of GDP) in Small states in 2009 to that in 2011?
Offer a very short reply. 1.13. What is the ratio of the Domestic credit (% of GDP) in Central African Republic in 2009 to that in 2011?
Provide a short and direct response. 0.71. What is the ratio of the Domestic credit (% of GDP) in Chad in 2009 to that in 2011?
Offer a terse response. 0.81. What is the ratio of the Domestic credit (% of GDP) of Colombia in 2009 to that in 2011?
Your response must be concise. 0.86. What is the ratio of the Domestic credit (% of GDP) in Small states in 2010 to that in 2011?
Provide a short and direct response. 1.04. What is the ratio of the Domestic credit (% of GDP) of Central African Republic in 2010 to that in 2011?
Give a very brief answer. 0.88. What is the ratio of the Domestic credit (% of GDP) in Chad in 2010 to that in 2011?
Your answer should be compact. 0.88. What is the ratio of the Domestic credit (% of GDP) in Colombia in 2010 to that in 2011?
Provide a short and direct response. 0.93. What is the difference between the highest and the second highest Domestic credit (% of GDP) in Small states?
Offer a very short reply. 3.11. What is the difference between the highest and the second highest Domestic credit (% of GDP) of Central African Republic?
Provide a short and direct response. 1.17. What is the difference between the highest and the second highest Domestic credit (% of GDP) of Chad?
Provide a short and direct response. 0.6. What is the difference between the highest and the second highest Domestic credit (% of GDP) of Colombia?
Offer a terse response. 2.61. What is the difference between the highest and the lowest Domestic credit (% of GDP) in Small states?
Your answer should be very brief. 5.59. What is the difference between the highest and the lowest Domestic credit (% of GDP) of Central African Republic?
Your response must be concise. 3.35. What is the difference between the highest and the lowest Domestic credit (% of GDP) in Chad?
Make the answer very short. 2.6. What is the difference between the highest and the lowest Domestic credit (% of GDP) in Colombia?
Provide a succinct answer. 7.76. 